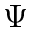<formula> <loc_0><loc_0><loc_500><loc_500>\Psi</formula> 